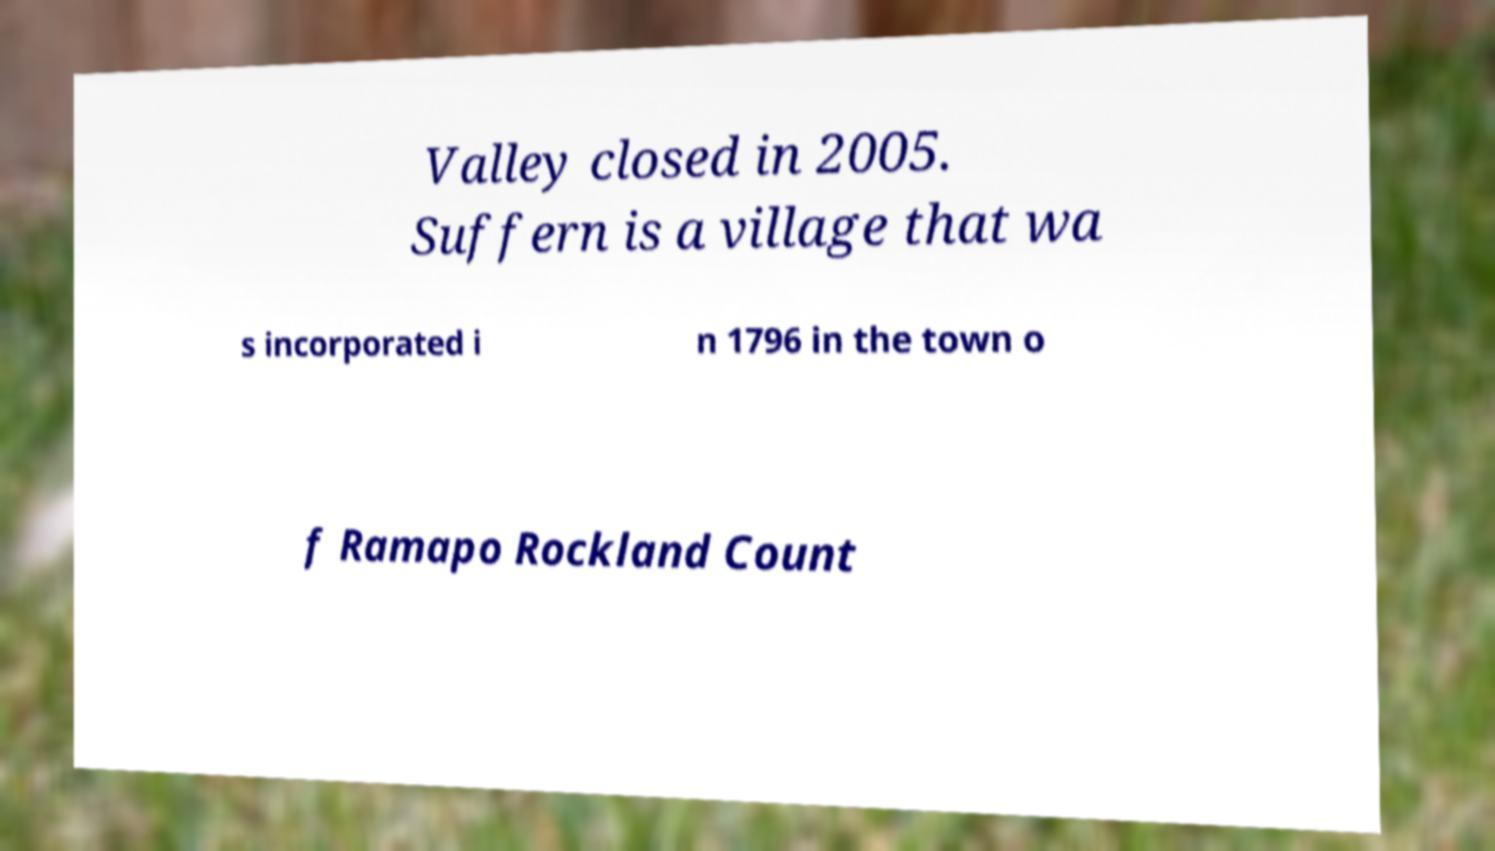For documentation purposes, I need the text within this image transcribed. Could you provide that? Valley closed in 2005. Suffern is a village that wa s incorporated i n 1796 in the town o f Ramapo Rockland Count 